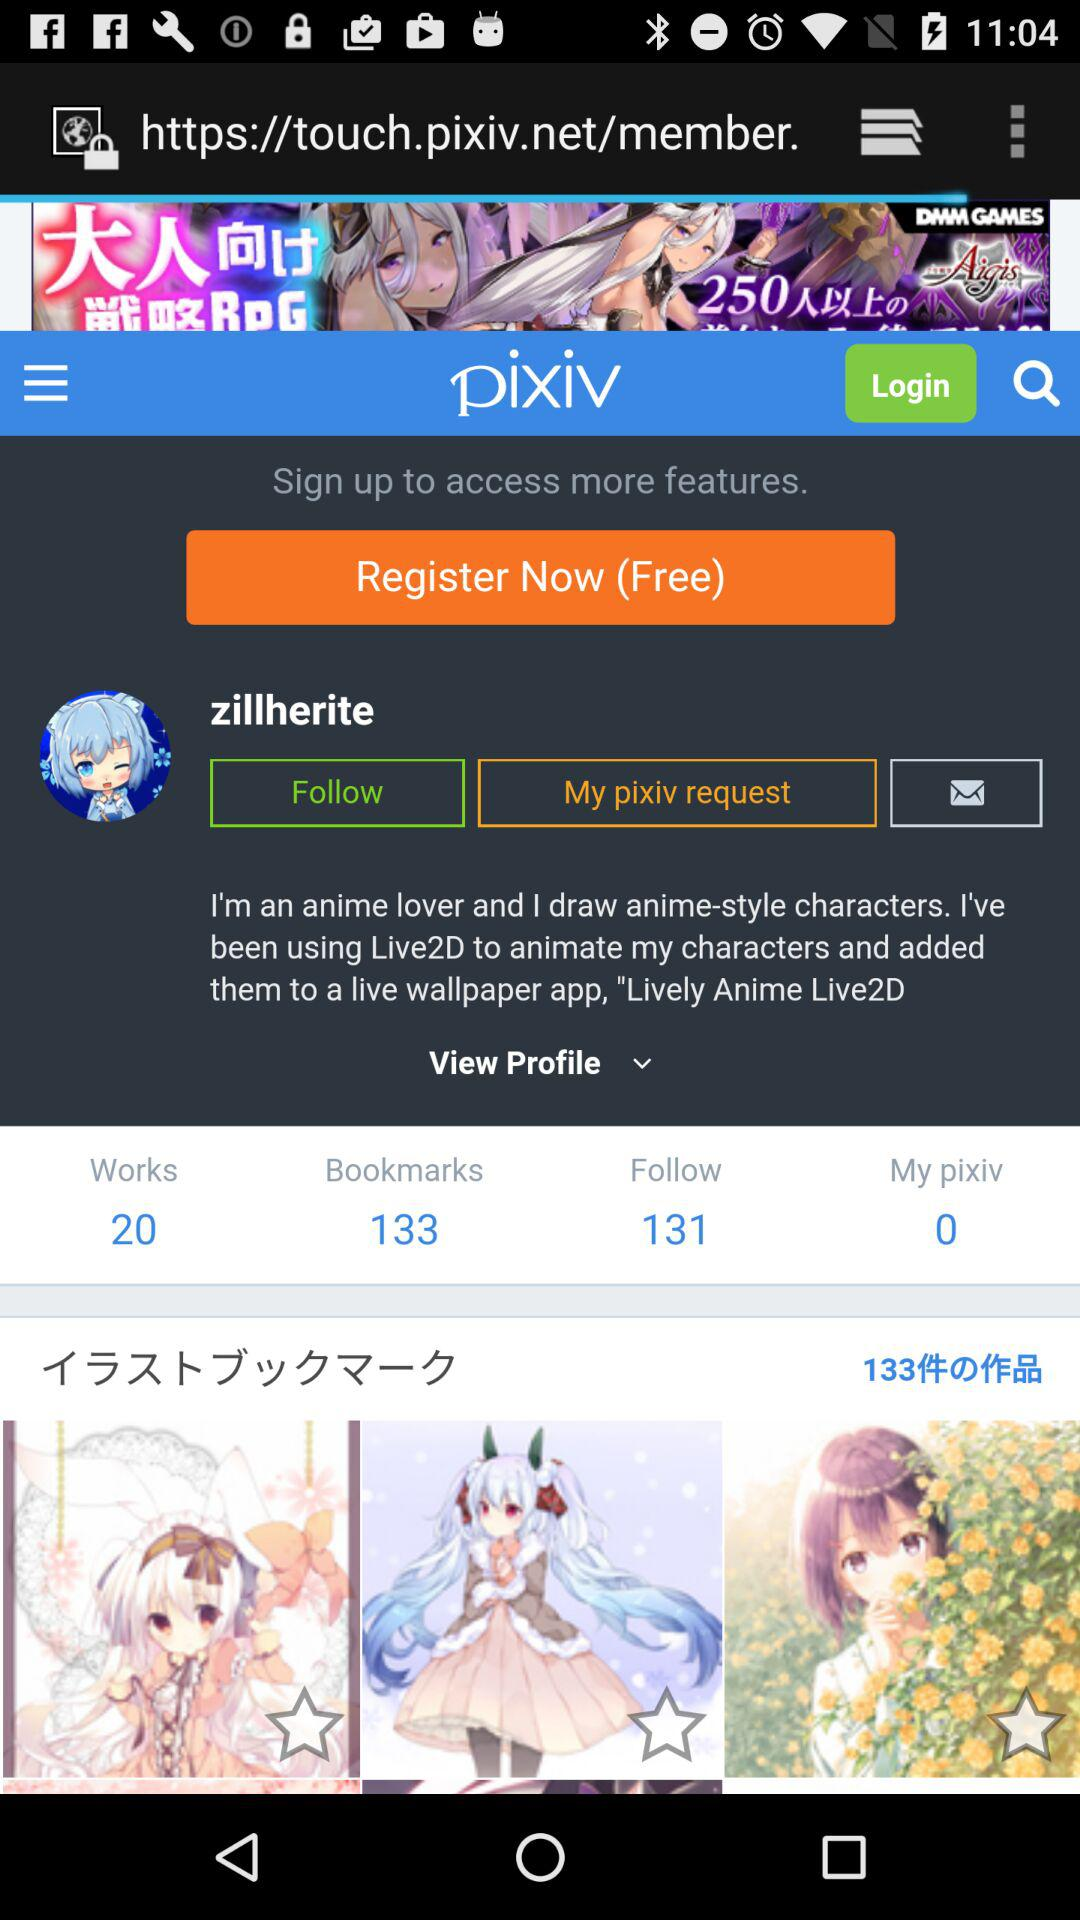What is the user name? The user name is zillherite. 